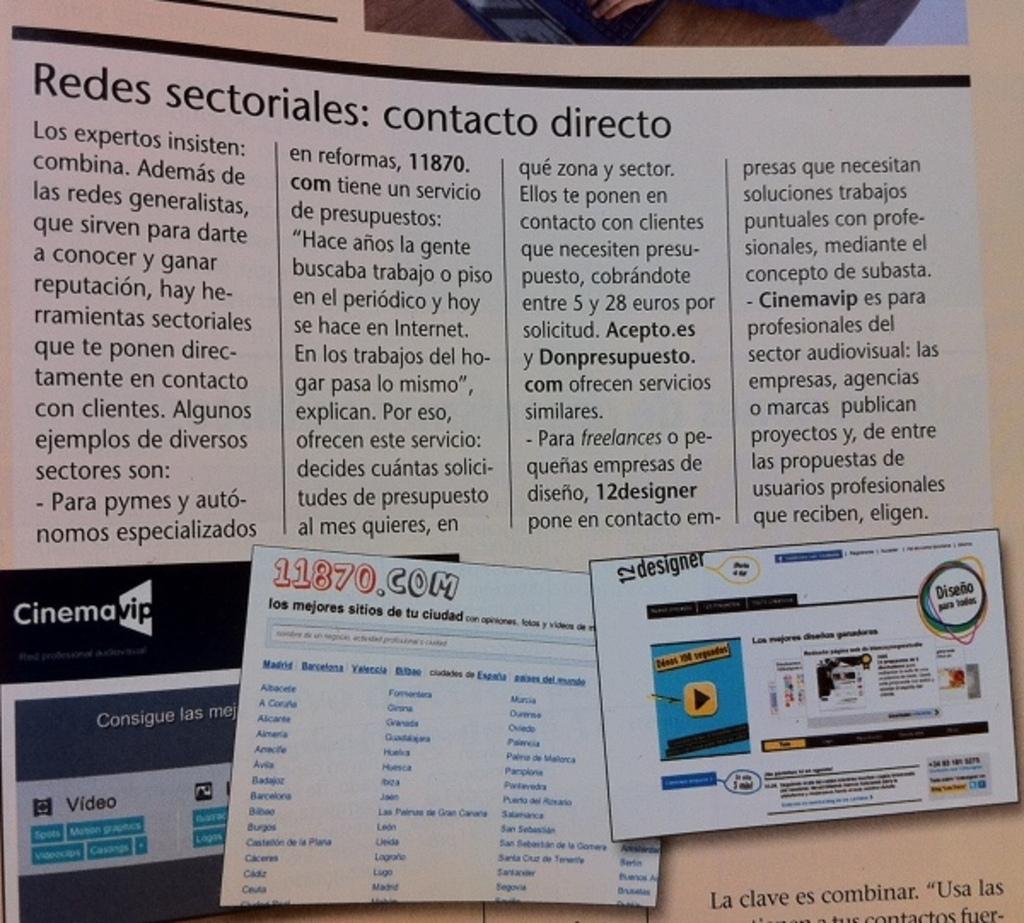Does the picture on the right say "designer"?
Your answer should be compact. Yes. What is the url on the middle picture on the bottom?
Your answer should be very brief. 11870.com. 